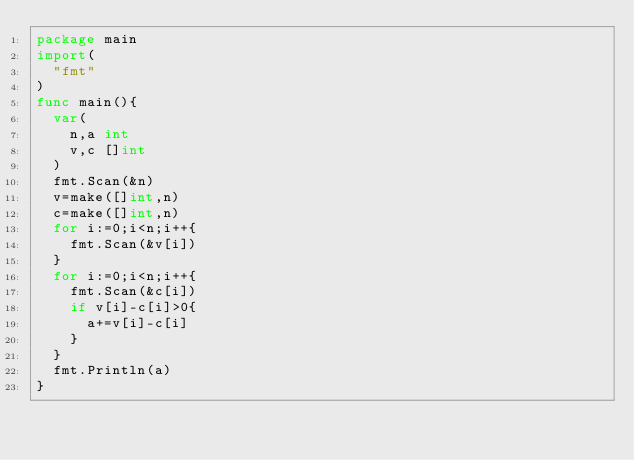<code> <loc_0><loc_0><loc_500><loc_500><_Go_>package main
import(
  "fmt"
)
func main(){
  var(
    n,a int
    v,c []int
  )
  fmt.Scan(&n)
  v=make([]int,n)
  c=make([]int,n)
  for i:=0;i<n;i++{
    fmt.Scan(&v[i])
  }
  for i:=0;i<n;i++{
    fmt.Scan(&c[i])
    if v[i]-c[i]>0{
      a+=v[i]-c[i]
    }
  }
  fmt.Println(a)
}</code> 